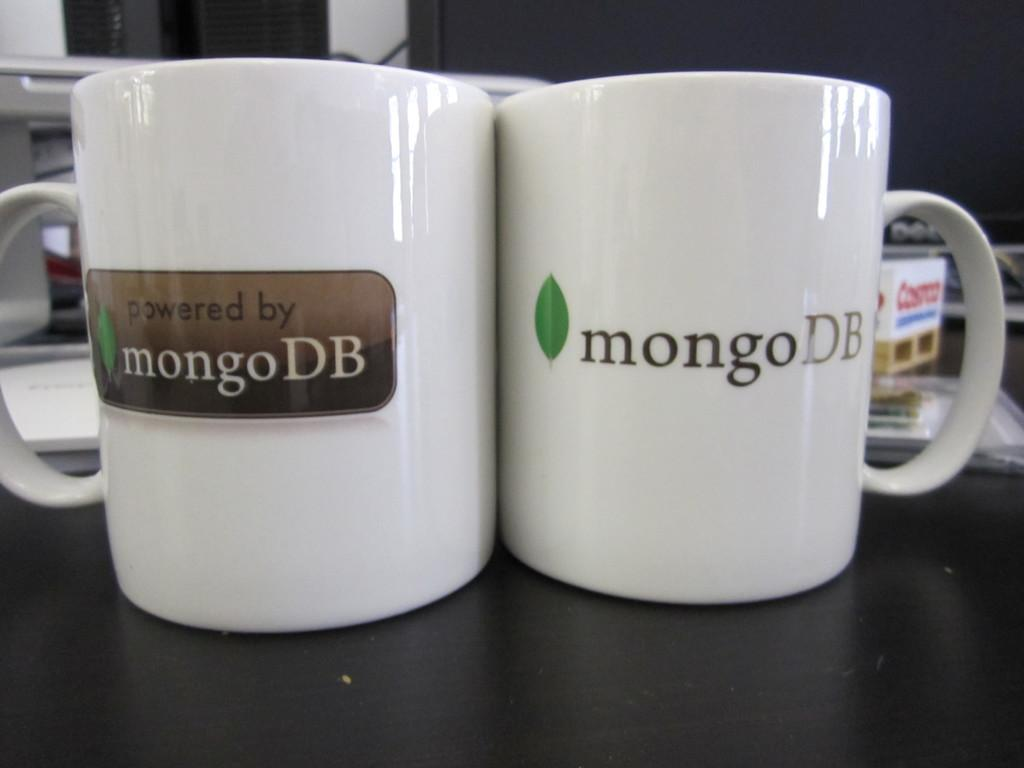<image>
Create a compact narrative representing the image presented. Two coffee cups sitting on a table with the logo mongo DB on them. 